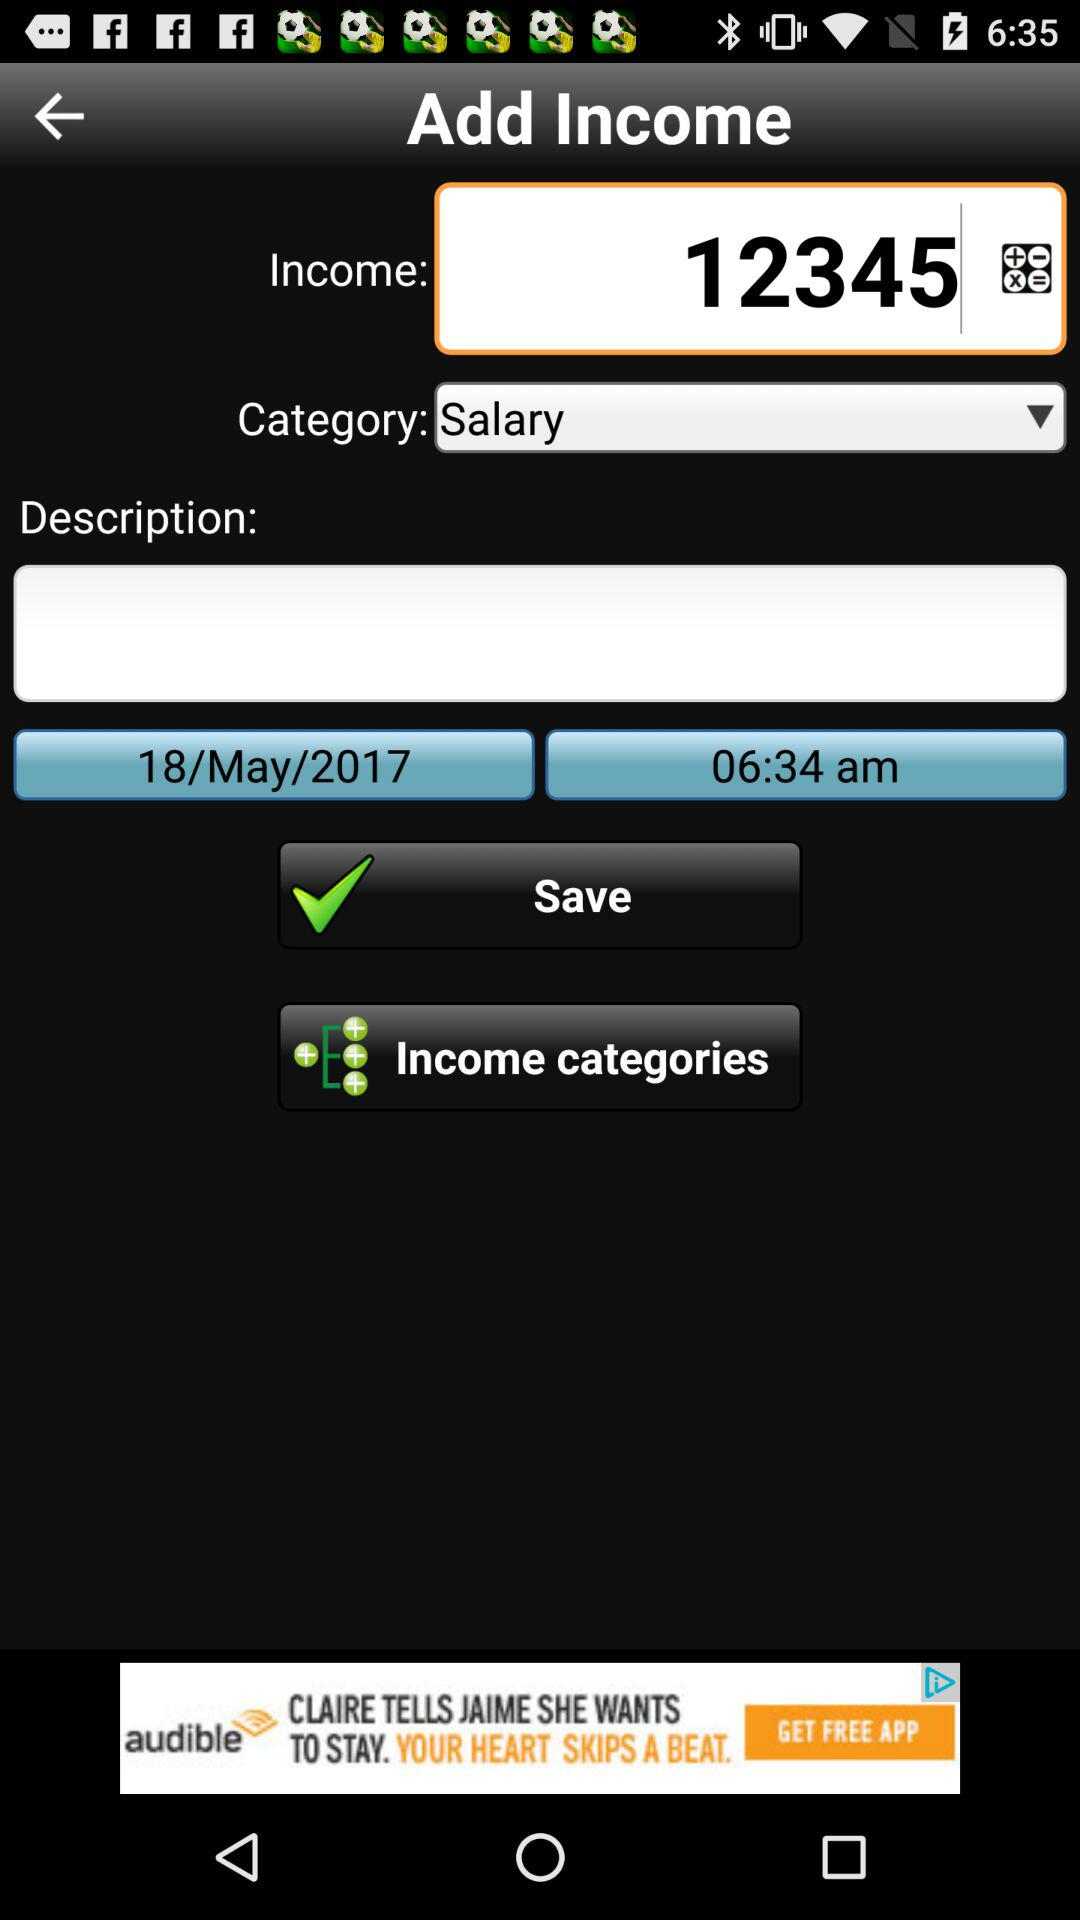What is the status of the "Save" option? The status is "on". 